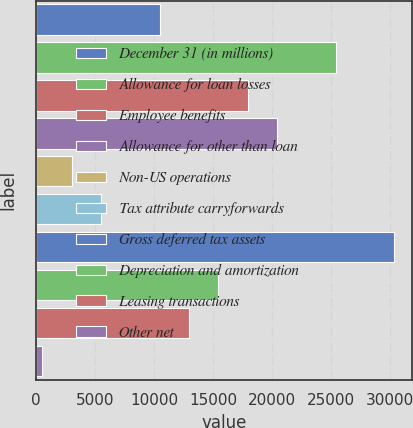<chart> <loc_0><loc_0><loc_500><loc_500><bar_chart><fcel>December 31 (in millions)<fcel>Allowance for loan losses<fcel>Employee benefits<fcel>Allowance for other than loan<fcel>Non-US operations<fcel>Tax attribute carryforwards<fcel>Gross deferred tax assets<fcel>Depreciation and amortization<fcel>Leasing transactions<fcel>Other net<nl><fcel>10478.6<fcel>25418<fcel>17948.3<fcel>20438.2<fcel>3008.9<fcel>5498.8<fcel>30397.8<fcel>15458.4<fcel>12968.5<fcel>519<nl></chart> 